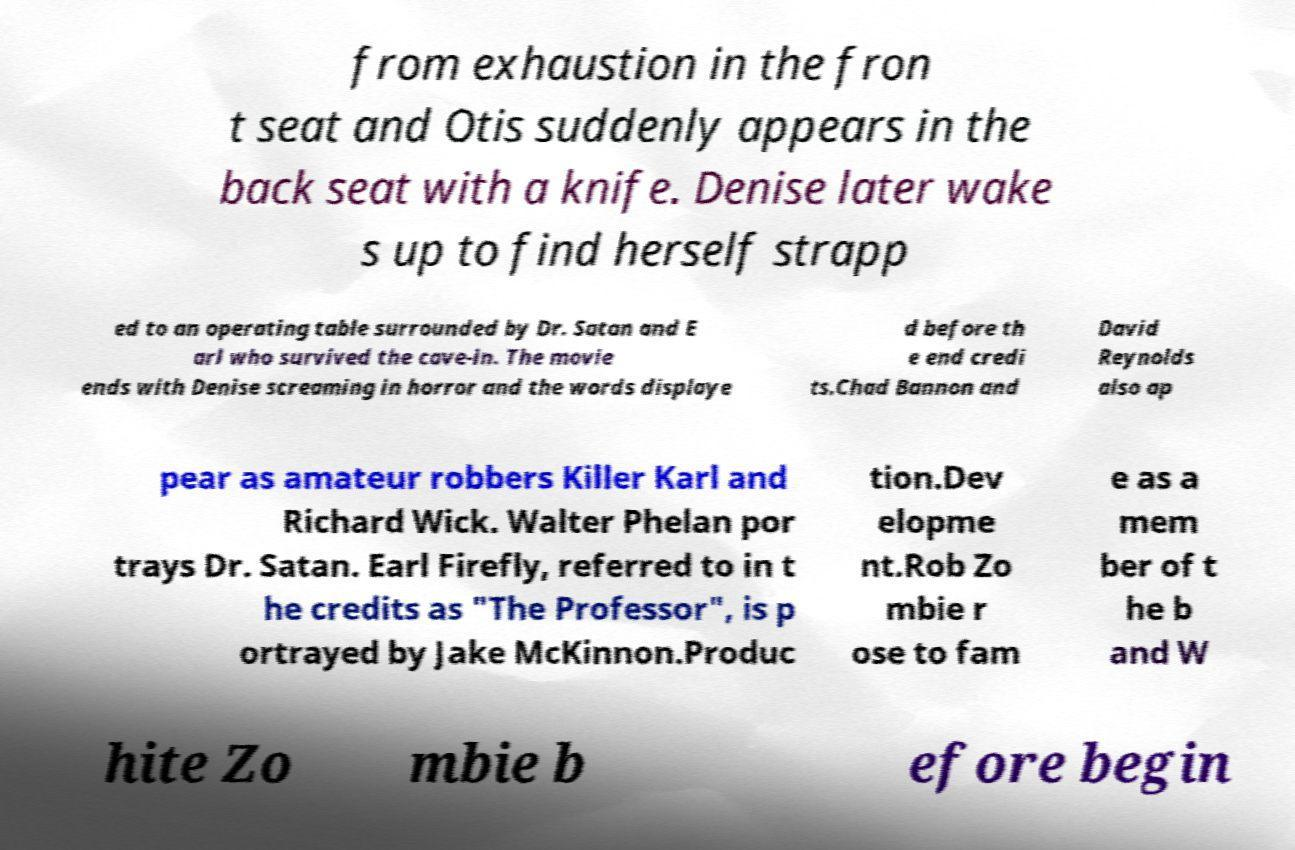Please read and relay the text visible in this image. What does it say? from exhaustion in the fron t seat and Otis suddenly appears in the back seat with a knife. Denise later wake s up to find herself strapp ed to an operating table surrounded by Dr. Satan and E arl who survived the cave-in. The movie ends with Denise screaming in horror and the words displaye d before th e end credi ts.Chad Bannon and David Reynolds also ap pear as amateur robbers Killer Karl and Richard Wick. Walter Phelan por trays Dr. Satan. Earl Firefly, referred to in t he credits as "The Professor", is p ortrayed by Jake McKinnon.Produc tion.Dev elopme nt.Rob Zo mbie r ose to fam e as a mem ber of t he b and W hite Zo mbie b efore begin 